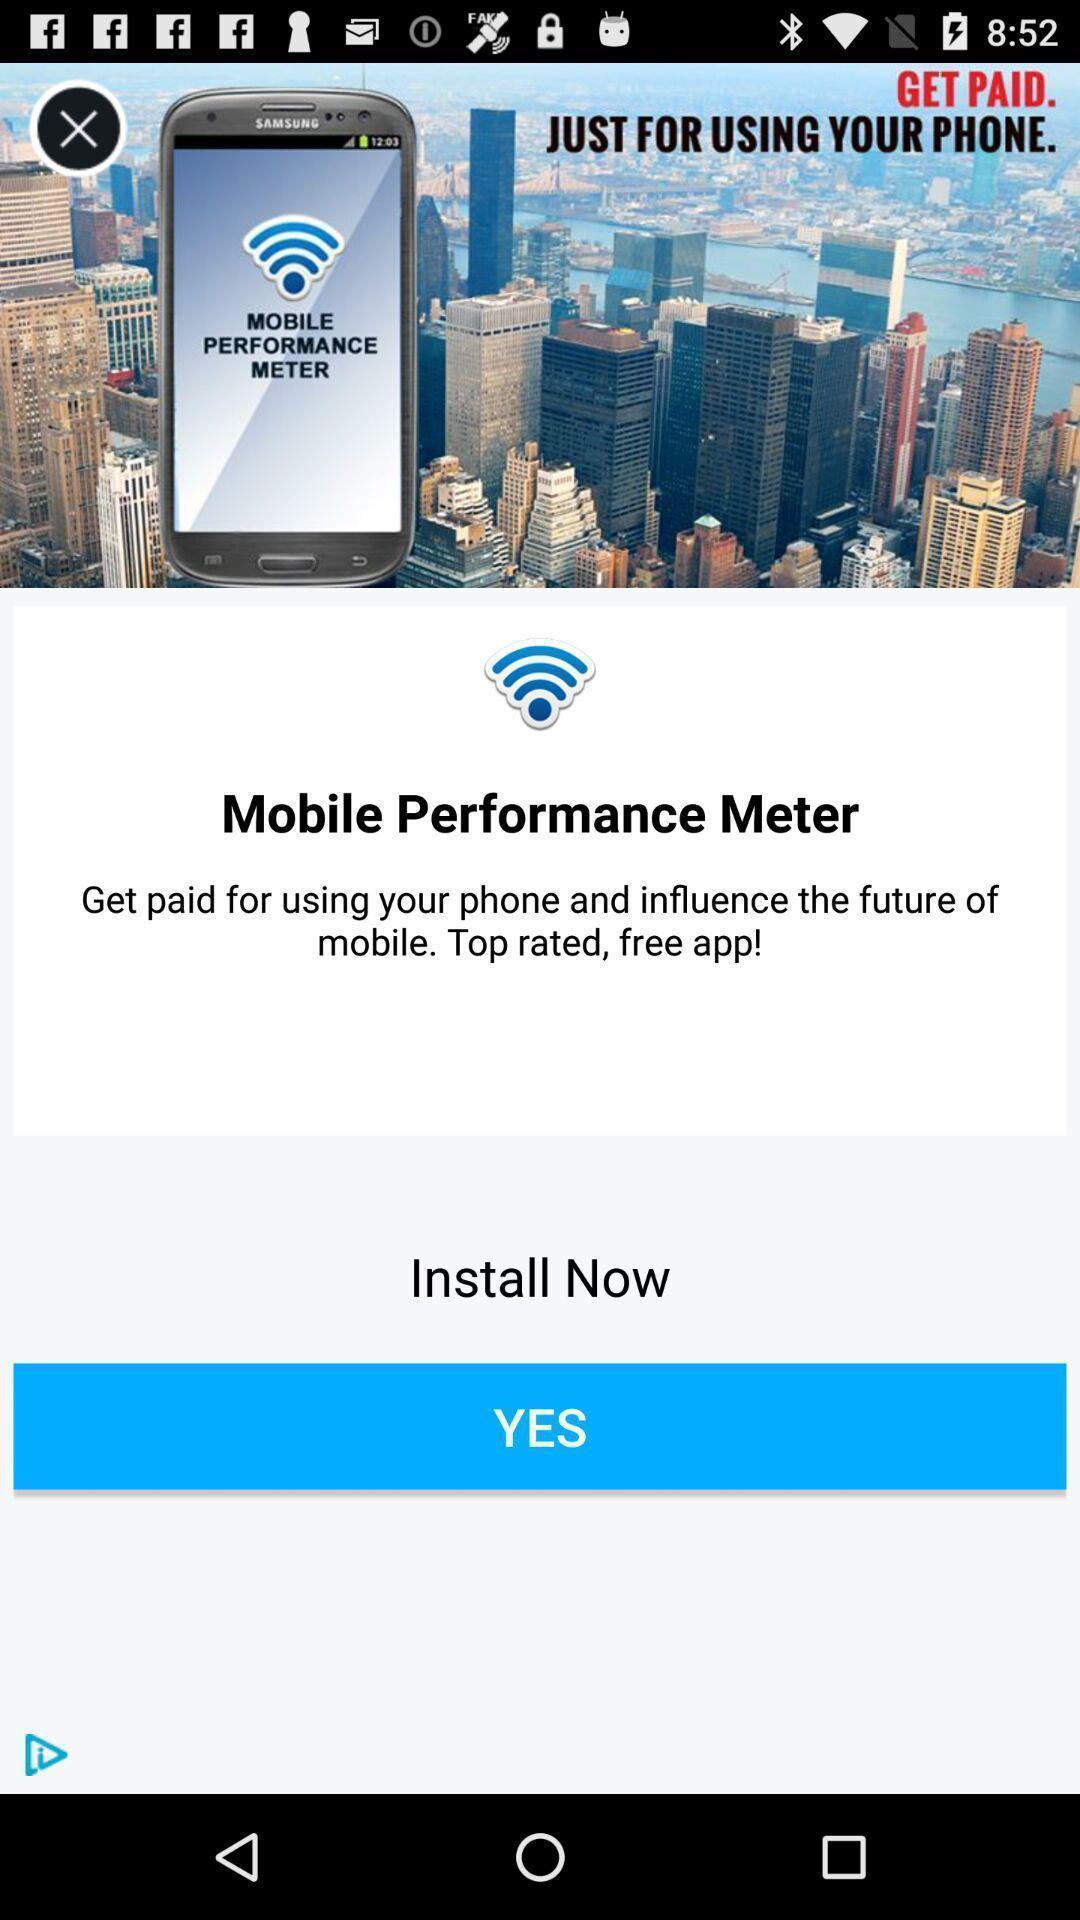Describe this image in words. Page showing an advertisement. 